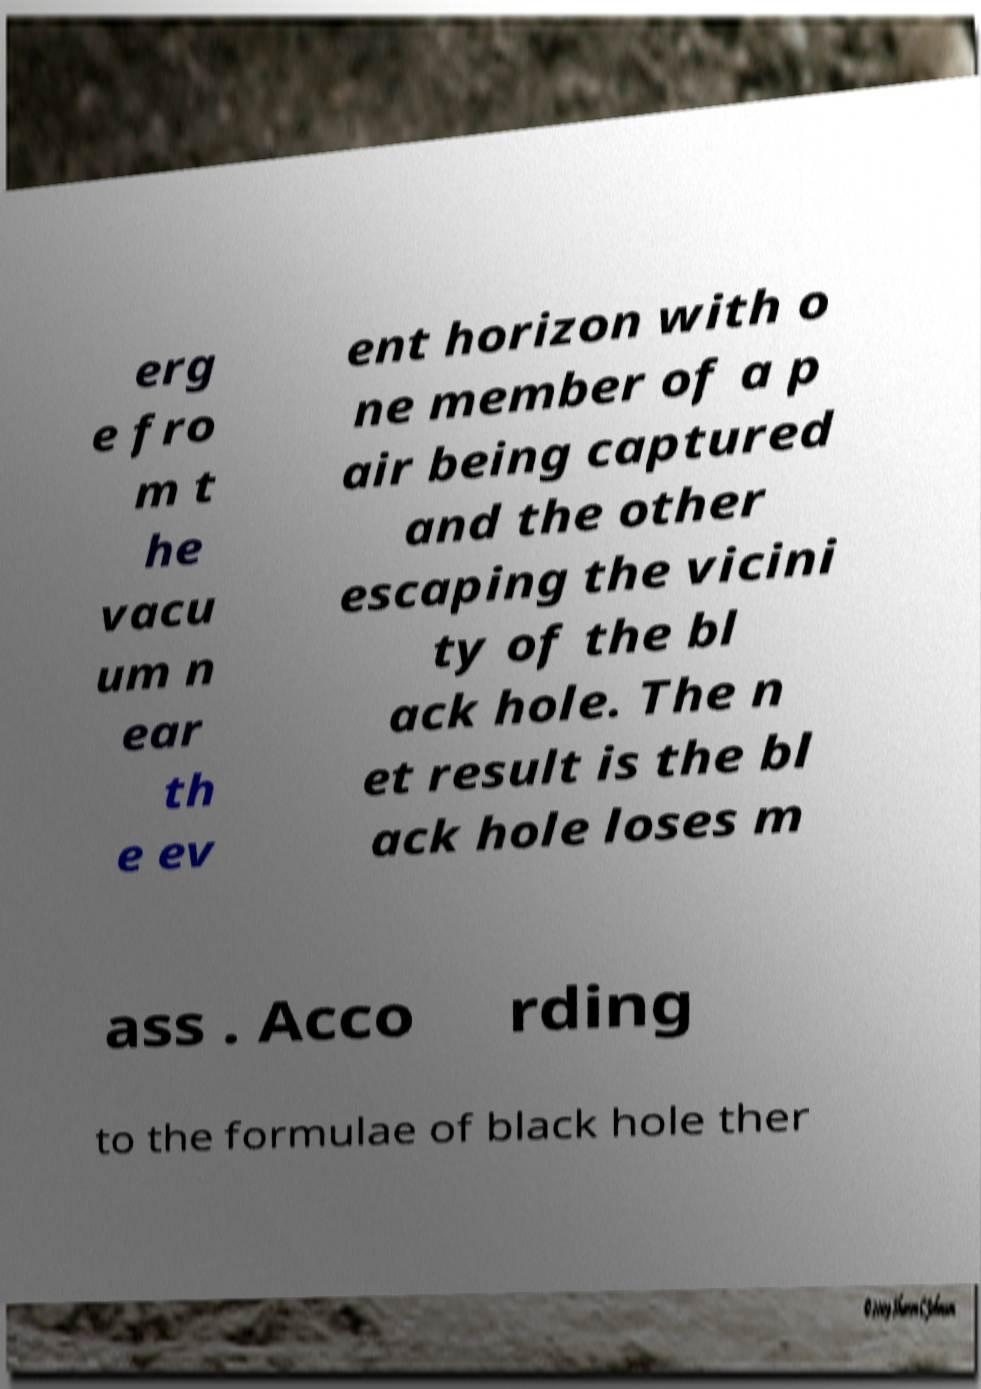Please read and relay the text visible in this image. What does it say? erg e fro m t he vacu um n ear th e ev ent horizon with o ne member of a p air being captured and the other escaping the vicini ty of the bl ack hole. The n et result is the bl ack hole loses m ass . Acco rding to the formulae of black hole ther 